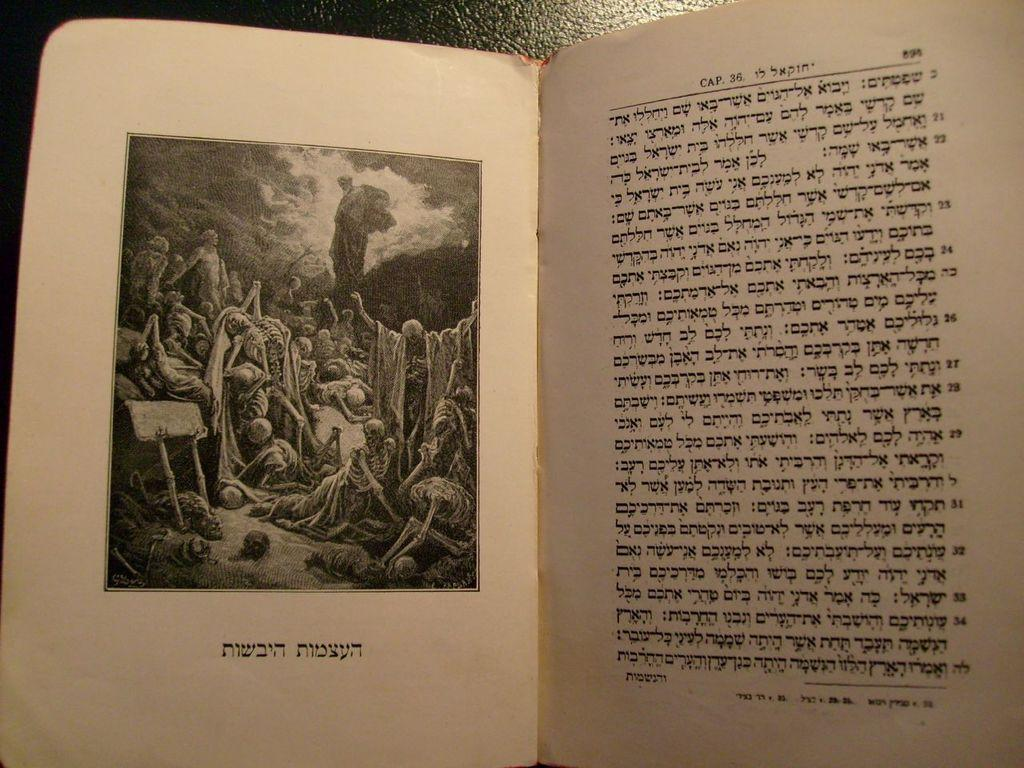<image>
Offer a succinct explanation of the picture presented. A foreign language book has the word cap 36 on it . 